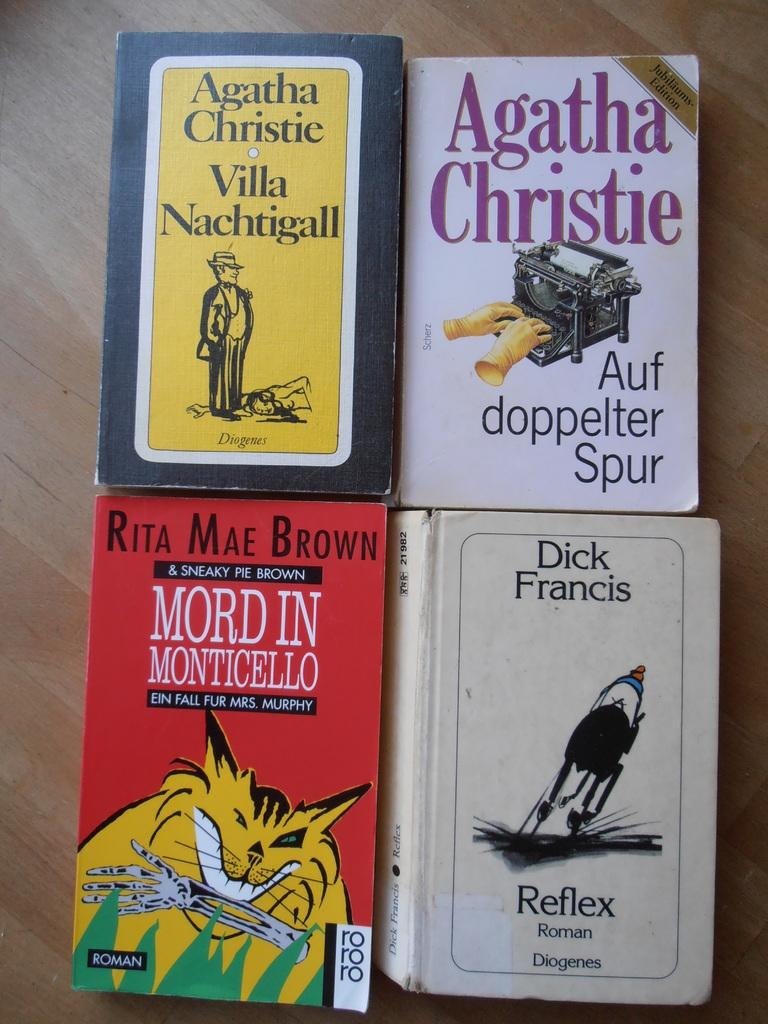<image>
Summarize the visual content of the image. A group of four mystery books by Agatha Christie and Rita Mae Brown. 